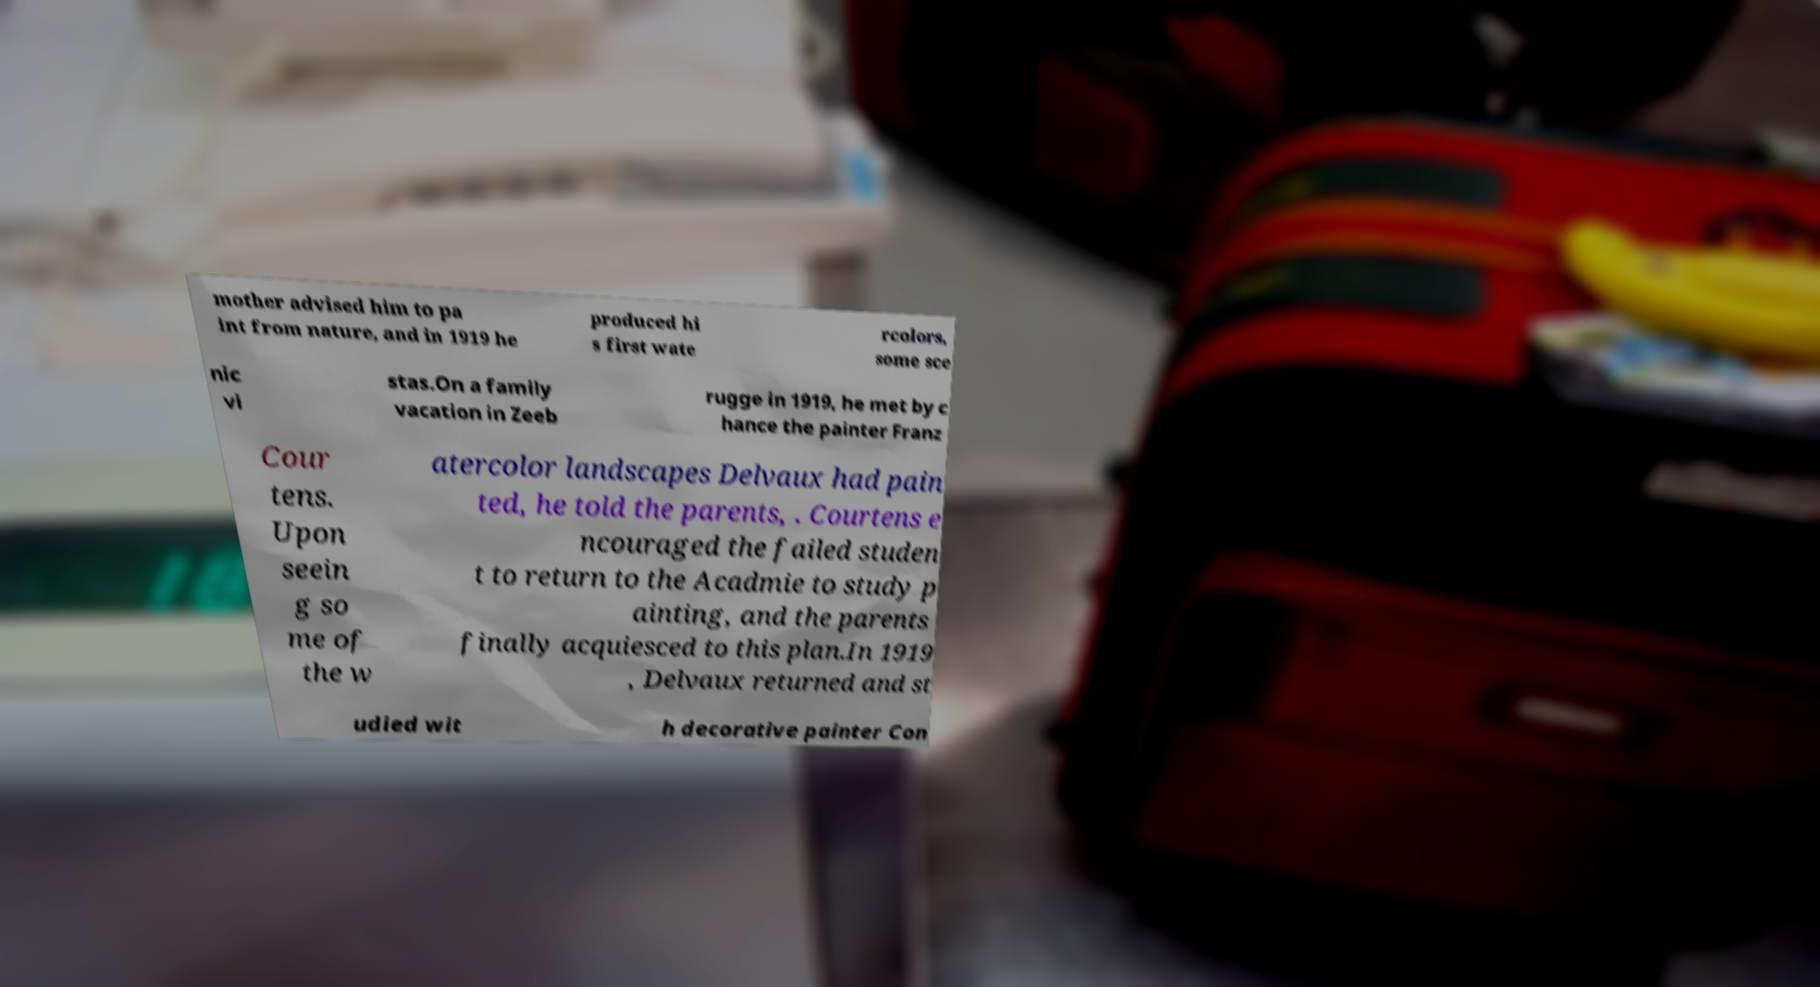There's text embedded in this image that I need extracted. Can you transcribe it verbatim? mother advised him to pa int from nature, and in 1919 he produced hi s first wate rcolors, some sce nic vi stas.On a family vacation in Zeeb rugge in 1919, he met by c hance the painter Franz Cour tens. Upon seein g so me of the w atercolor landscapes Delvaux had pain ted, he told the parents, . Courtens e ncouraged the failed studen t to return to the Acadmie to study p ainting, and the parents finally acquiesced to this plan.In 1919 , Delvaux returned and st udied wit h decorative painter Con 